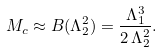<formula> <loc_0><loc_0><loc_500><loc_500>M _ { c } \approx B ( \Lambda _ { 2 } ^ { 2 } ) = \frac { \Lambda _ { 1 } ^ { 3 } } { 2 \, \Lambda _ { 2 } ^ { 2 } } .</formula> 